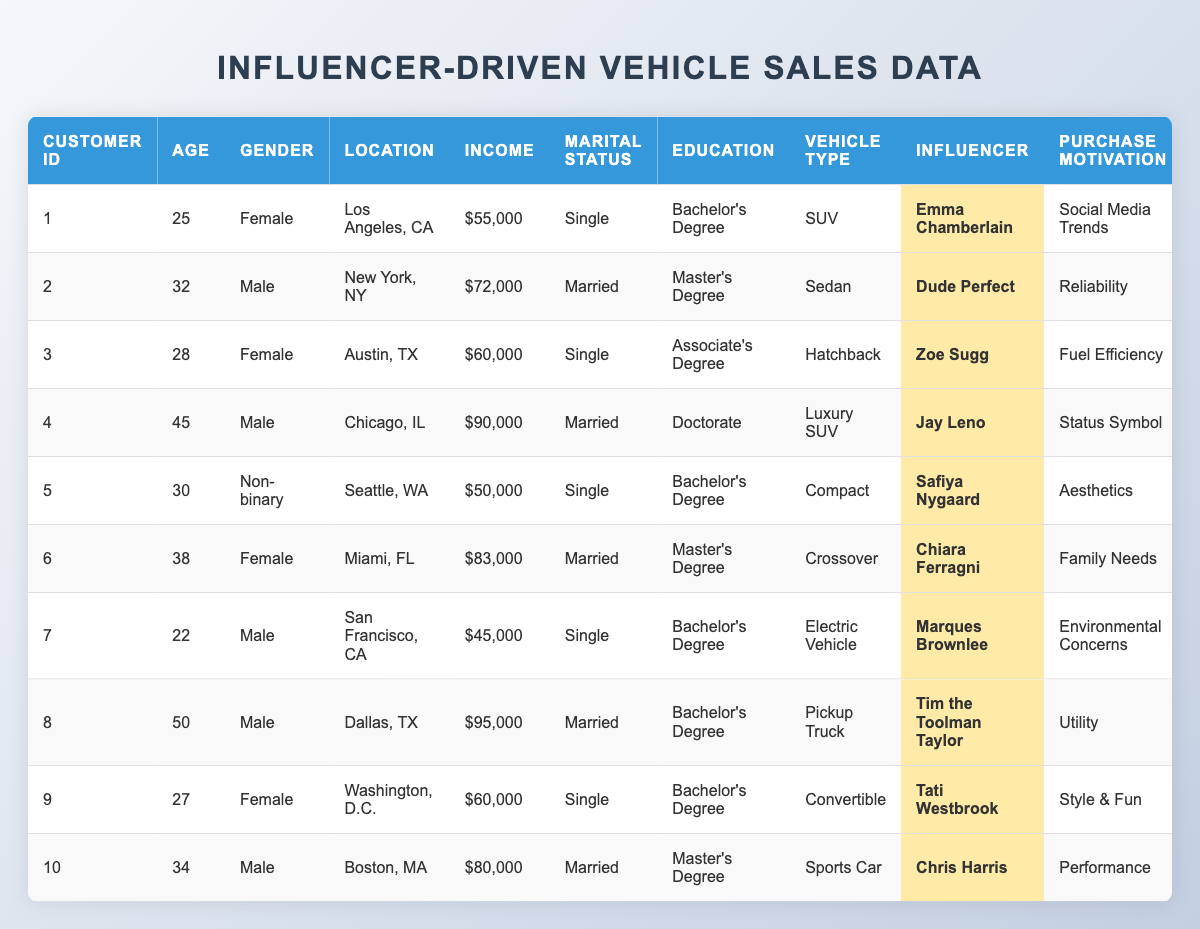What is the Income of the customer who prefers SUVs? The customer that prefers SUVs is Customer ID 1, and their income is listed as $55,000.
Answer: $55,000 How many customers are single? By counting the rows in the table where Marital Status is "Single," we find there are 5 customers (Customer IDs 1, 3, 5, 7, and 9).
Answer: 5 What is the most preferred vehicle type among customers followed by influencers? By checking the Vehicle Type column, we see "SUV" is designated for Customer ID 1, while others like Sedan, Hatchback, etc., are less common; however, there is no outright majority so they all have varied preferences.
Answer: No single most preferred type Which influencer is followed by customers with a doctorate degree? The table shows that only Customer ID 4, who followed Jay Leno and has a doctorate degree, is identified.
Answer: Jay Leno What is the average spending of female customers? Summing the Average Spending of female customers (Customer IDs 1, 3, 6, and 9) gives us $32,000 + $22,000 + $40,000 + $35,000 = $129,000. There are 4 female customers, so the average is $129,000 / 4 = $32,250.
Answer: $32,250 Do all customers with a Bachelor’s degree prefer SUVs? Customer ID 1 prefers an SUV, but Customer IDs 3, 5, 9 have different preferences (Hatchback, Compact, and Convertible respectively), so not all prefer SUVs.
Answer: No What is the purchase frequency of the customer who follows Marques Brownlee? The purchase frequency for the customer who follows Marques Brownlee (Customer ID 7) is listed as every 5 years.
Answer: Every 5 years Are there any customers that prefer luxury vehicles? Yes, Customer ID 4 prefers a Luxury SUV, indicating there is a preference for luxury vehicles among the customers.
Answer: Yes What is the total income of all customers living in Texas? The customers living in Texas are Customer IDs 3 (Austin, $60,000), 8 (Dallas, $95,000), and their total income is $60,000 + $95,000 = $155,000.
Answer: $155,000 How many customers purchase vehicles every 3 years? By counting the rows for Purchase Frequency labeled “Every 3 years,” there are 3 customers (Customer IDs 2, 6, and 9).
Answer: 3 What is the average age of customers who follow influencers for their purchase motivation? The ages of the customers are 25, 32, 28, 45, 30, 38, 22, 50, 27, and 34. Their sum is 25 + 32 + 28 + 45 + 30 + 38 + 22 + 50 + 27 + 34 = 331, divided by 10 customers gives an average of 33.1.
Answer: 33.1 Which customer has the highest income and vehicle spending preference? Customer ID 8 has the highest income at $95,000 and prefers a Pickup Truck with an average spending of $50,000, making him the highest in both metrics among the list.
Answer: Customer ID 8 What different purchase motivations do single customers have? The motivations for single customers (IDs 1, 3, 5, 7, and 9) include Social Media Trends, Fuel Efficiency, Aesthetics, Environmental Concerns, and Style & Fun, respectively, showing diverse preferences.
Answer: Diverse motivations 